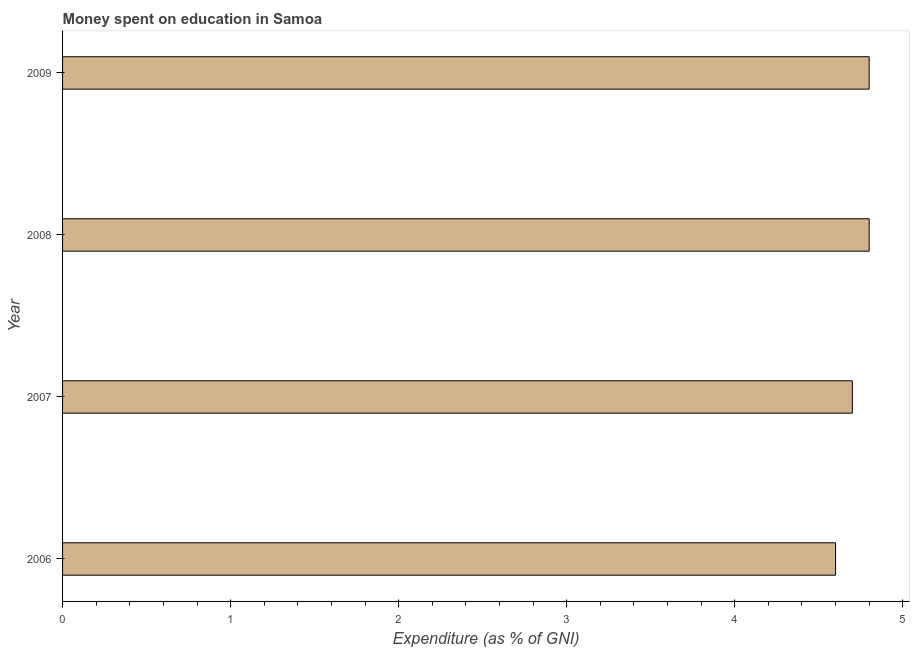Does the graph contain any zero values?
Your answer should be compact. No. Does the graph contain grids?
Ensure brevity in your answer.  No. What is the title of the graph?
Your answer should be compact. Money spent on education in Samoa. What is the label or title of the X-axis?
Offer a very short reply. Expenditure (as % of GNI). What is the expenditure on education in 2007?
Provide a succinct answer. 4.7. Across all years, what is the minimum expenditure on education?
Keep it short and to the point. 4.6. In which year was the expenditure on education minimum?
Keep it short and to the point. 2006. What is the sum of the expenditure on education?
Provide a short and direct response. 18.9. What is the average expenditure on education per year?
Make the answer very short. 4.72. What is the median expenditure on education?
Offer a very short reply. 4.75. In how many years, is the expenditure on education greater than 0.2 %?
Offer a terse response. 4. What is the ratio of the expenditure on education in 2006 to that in 2008?
Offer a terse response. 0.96. Is the difference between the expenditure on education in 2006 and 2008 greater than the difference between any two years?
Your response must be concise. Yes. What is the difference between the highest and the second highest expenditure on education?
Provide a succinct answer. 0. Are all the bars in the graph horizontal?
Give a very brief answer. Yes. How many years are there in the graph?
Provide a short and direct response. 4. What is the difference between two consecutive major ticks on the X-axis?
Make the answer very short. 1. Are the values on the major ticks of X-axis written in scientific E-notation?
Give a very brief answer. No. What is the Expenditure (as % of GNI) of 2006?
Make the answer very short. 4.6. What is the Expenditure (as % of GNI) of 2007?
Your response must be concise. 4.7. What is the difference between the Expenditure (as % of GNI) in 2006 and 2008?
Provide a short and direct response. -0.2. What is the difference between the Expenditure (as % of GNI) in 2006 and 2009?
Your answer should be very brief. -0.2. What is the difference between the Expenditure (as % of GNI) in 2007 and 2008?
Your answer should be very brief. -0.1. What is the difference between the Expenditure (as % of GNI) in 2007 and 2009?
Your answer should be very brief. -0.1. What is the ratio of the Expenditure (as % of GNI) in 2006 to that in 2007?
Your answer should be very brief. 0.98. What is the ratio of the Expenditure (as % of GNI) in 2006 to that in 2008?
Your response must be concise. 0.96. What is the ratio of the Expenditure (as % of GNI) in 2006 to that in 2009?
Provide a short and direct response. 0.96. What is the ratio of the Expenditure (as % of GNI) in 2008 to that in 2009?
Make the answer very short. 1. 